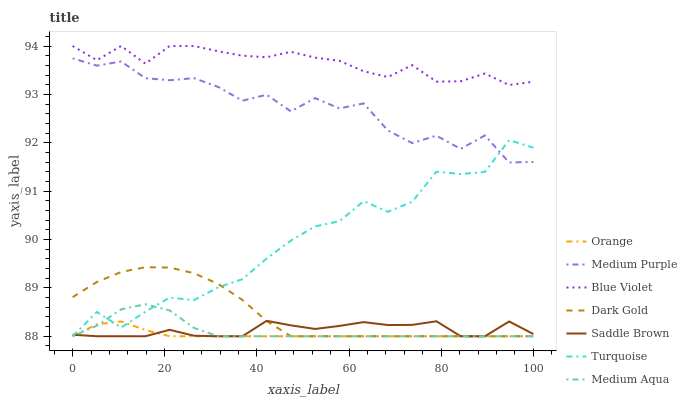Does Orange have the minimum area under the curve?
Answer yes or no. Yes. Does Blue Violet have the maximum area under the curve?
Answer yes or no. Yes. Does Dark Gold have the minimum area under the curve?
Answer yes or no. No. Does Dark Gold have the maximum area under the curve?
Answer yes or no. No. Is Orange the smoothest?
Answer yes or no. Yes. Is Medium Purple the roughest?
Answer yes or no. Yes. Is Dark Gold the smoothest?
Answer yes or no. No. Is Dark Gold the roughest?
Answer yes or no. No. Does Turquoise have the lowest value?
Answer yes or no. Yes. Does Medium Purple have the lowest value?
Answer yes or no. No. Does Blue Violet have the highest value?
Answer yes or no. Yes. Does Dark Gold have the highest value?
Answer yes or no. No. Is Saddle Brown less than Blue Violet?
Answer yes or no. Yes. Is Blue Violet greater than Saddle Brown?
Answer yes or no. Yes. Does Medium Aqua intersect Orange?
Answer yes or no. Yes. Is Medium Aqua less than Orange?
Answer yes or no. No. Is Medium Aqua greater than Orange?
Answer yes or no. No. Does Saddle Brown intersect Blue Violet?
Answer yes or no. No. 